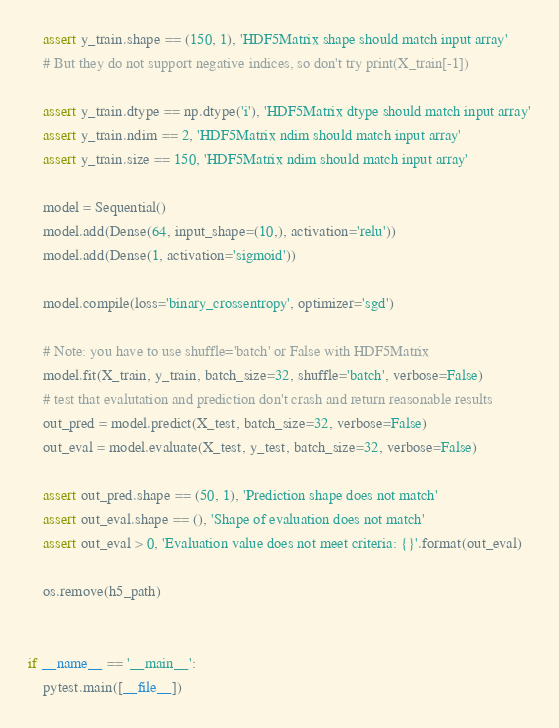<code> <loc_0><loc_0><loc_500><loc_500><_Python_>    assert y_train.shape == (150, 1), 'HDF5Matrix shape should match input array'
    # But they do not support negative indices, so don't try print(X_train[-1])

    assert y_train.dtype == np.dtype('i'), 'HDF5Matrix dtype should match input array'
    assert y_train.ndim == 2, 'HDF5Matrix ndim should match input array'
    assert y_train.size == 150, 'HDF5Matrix ndim should match input array'

    model = Sequential()
    model.add(Dense(64, input_shape=(10,), activation='relu'))
    model.add(Dense(1, activation='sigmoid'))

    model.compile(loss='binary_crossentropy', optimizer='sgd')

    # Note: you have to use shuffle='batch' or False with HDF5Matrix
    model.fit(X_train, y_train, batch_size=32, shuffle='batch', verbose=False)
    # test that evalutation and prediction don't crash and return reasonable results
    out_pred = model.predict(X_test, batch_size=32, verbose=False)
    out_eval = model.evaluate(X_test, y_test, batch_size=32, verbose=False)

    assert out_pred.shape == (50, 1), 'Prediction shape does not match'
    assert out_eval.shape == (), 'Shape of evaluation does not match'
    assert out_eval > 0, 'Evaluation value does not meet criteria: {}'.format(out_eval)

    os.remove(h5_path)


if __name__ == '__main__':
    pytest.main([__file__])
</code> 